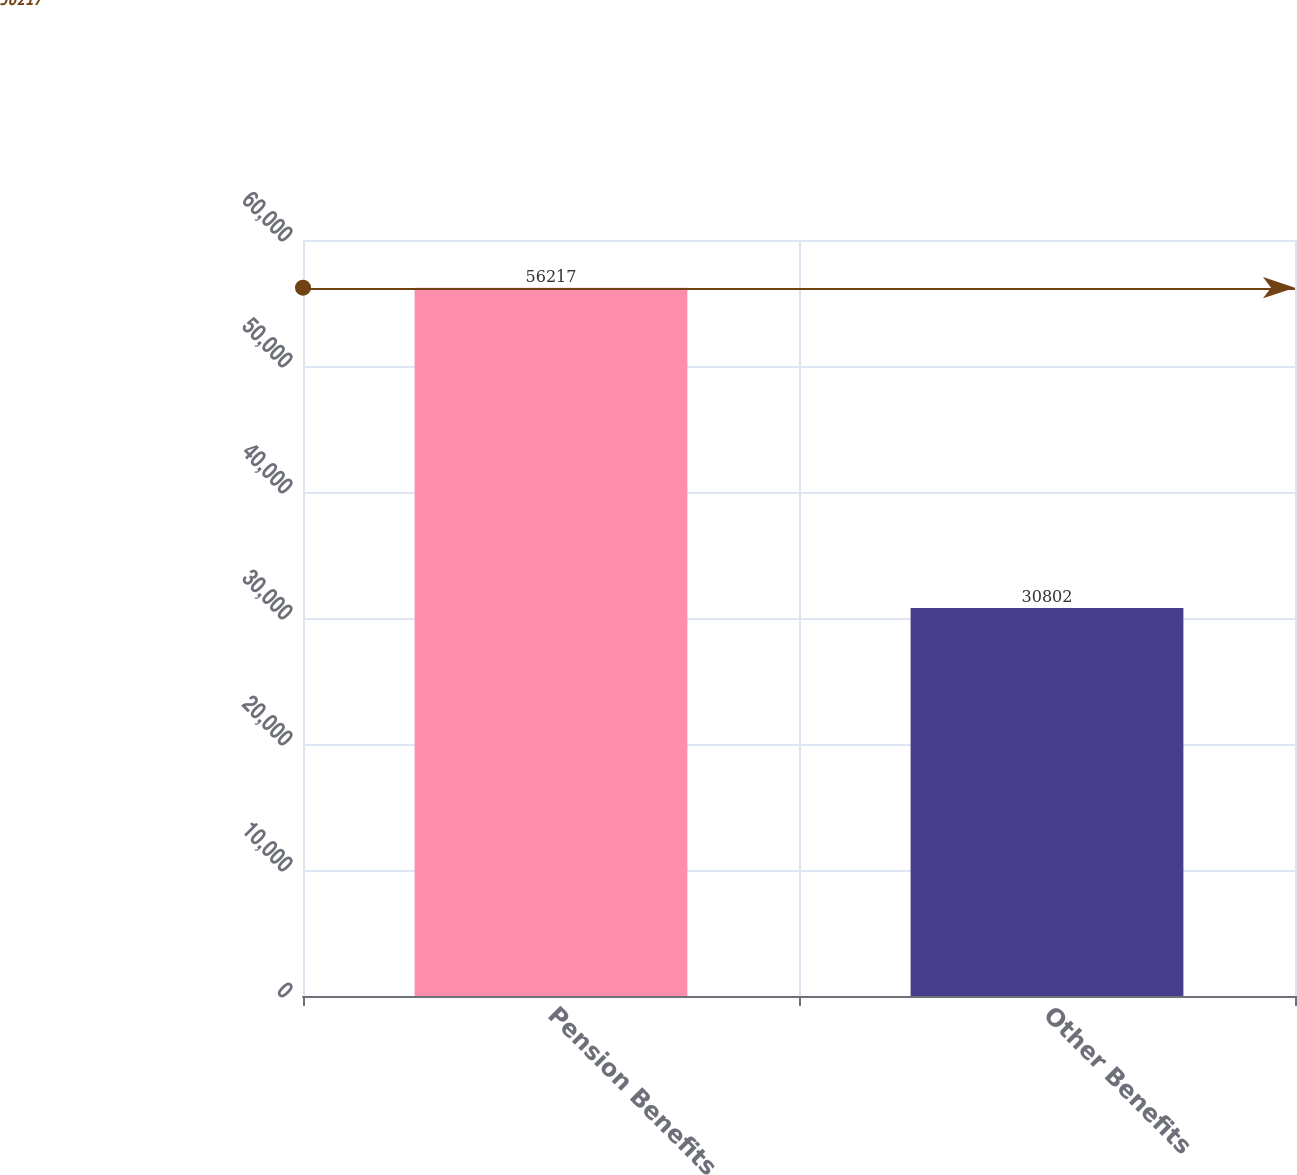<chart> <loc_0><loc_0><loc_500><loc_500><bar_chart><fcel>Pension Benefits<fcel>Other Benefits<nl><fcel>56217<fcel>30802<nl></chart> 